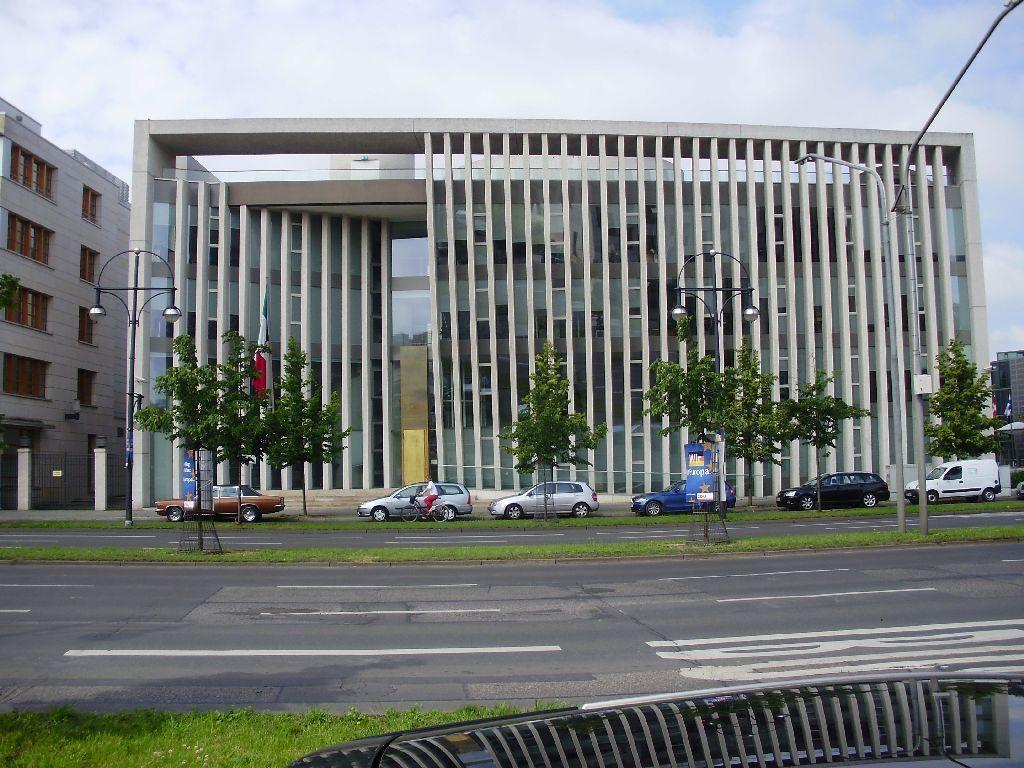How would you summarize this image in a sentence or two? In this image we can see buildings, there are vehicles on the road, a person is riding on the bicycle, there are boards with text on it, there are trees, and the grass, also we can see the sky. 